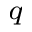<formula> <loc_0><loc_0><loc_500><loc_500>^ { q }</formula> 